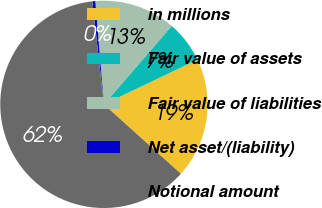Convert chart to OTSL. <chart><loc_0><loc_0><loc_500><loc_500><pie_chart><fcel>in millions<fcel>Fair value of assets<fcel>Fair value of liabilities<fcel>Net asset/(liability)<fcel>Notional amount<nl><fcel>18.78%<fcel>6.56%<fcel>12.67%<fcel>0.45%<fcel>61.53%<nl></chart> 